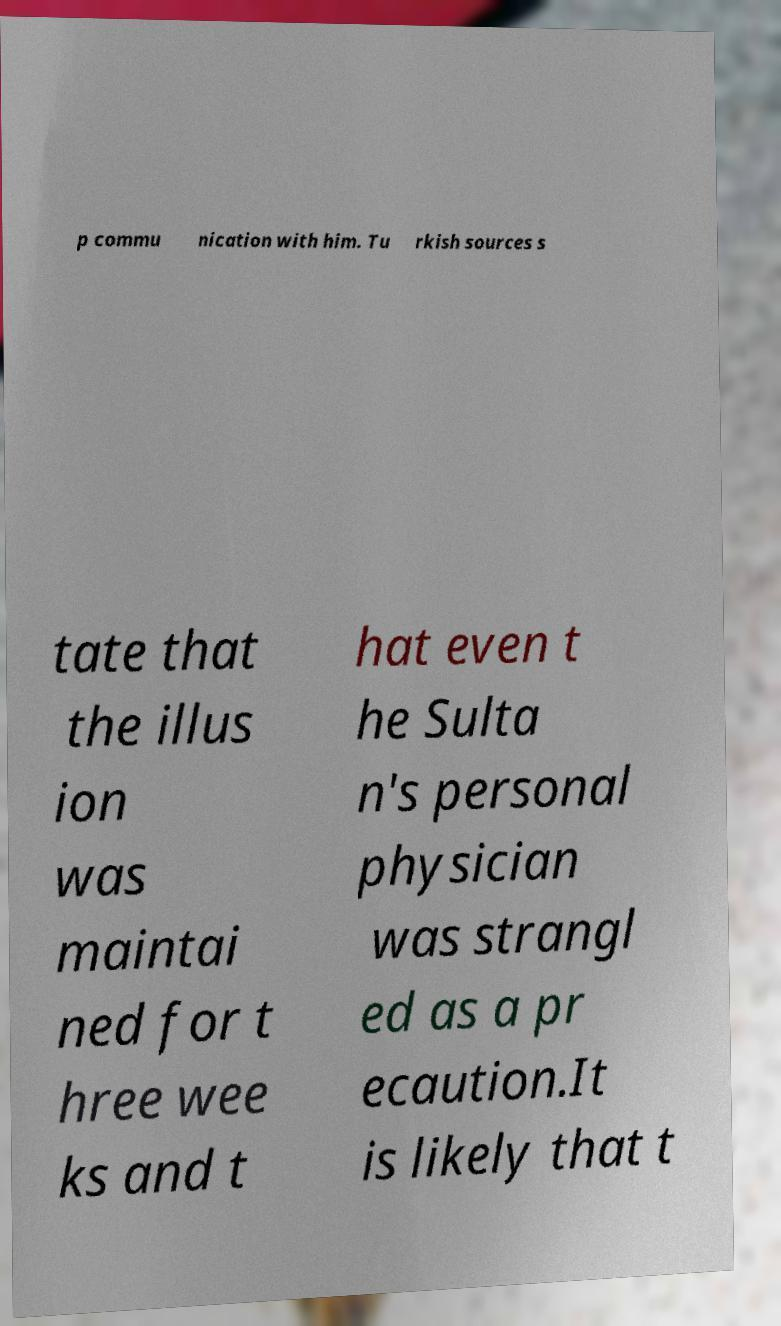Please read and relay the text visible in this image. What does it say? p commu nication with him. Tu rkish sources s tate that the illus ion was maintai ned for t hree wee ks and t hat even t he Sulta n's personal physician was strangl ed as a pr ecaution.It is likely that t 